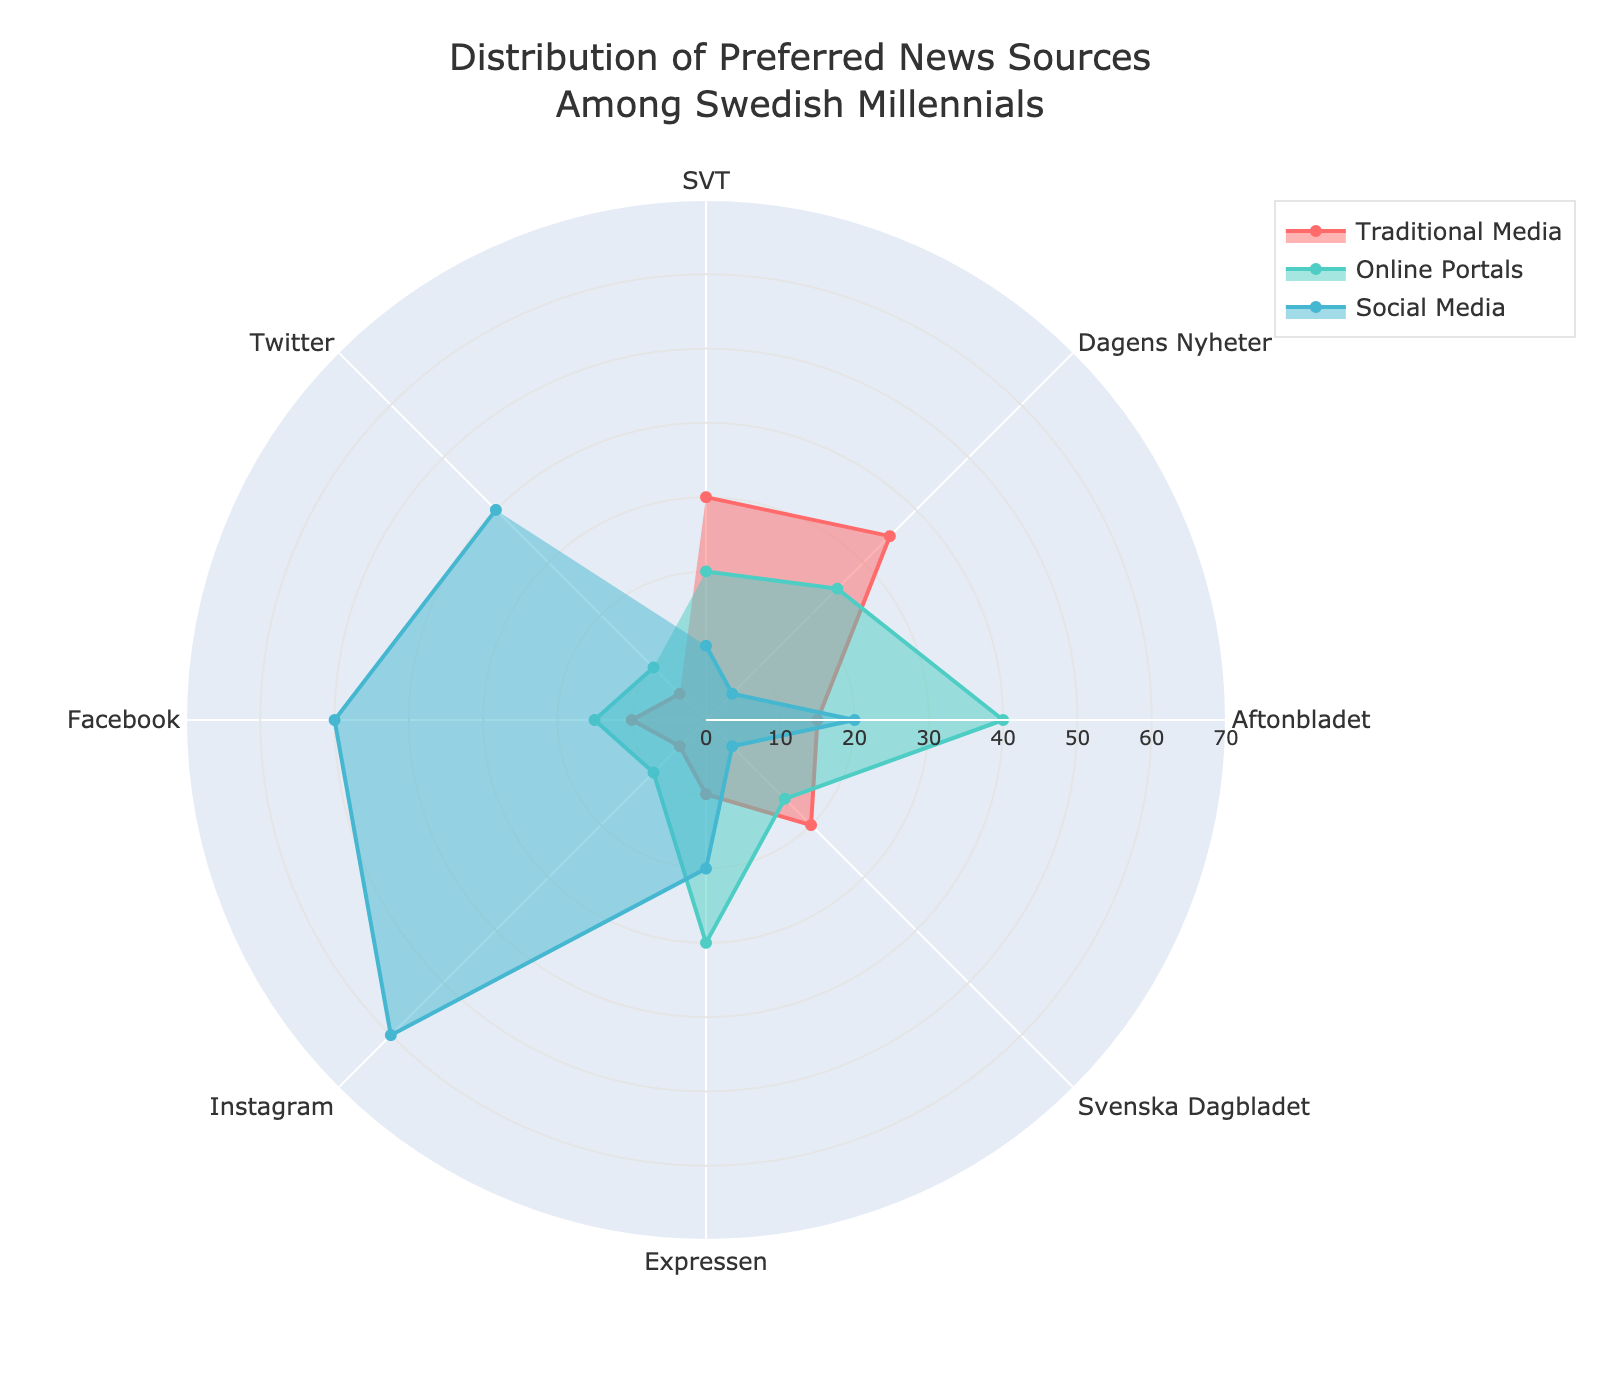What is the highest value for Traditional Media in the chart? The highest value is plotted by looking at where the red-colored area representing Traditional Media peaks. The peak is at Dagens Nyheter with a value of 35.
Answer: 35 Which news source is most preferred on Social Media? The news source with the highest value for Social Media can be found by observing where the blue-colored area peaks. The highest value is Instagram with 60.
Answer: Instagram What is the combined preference for Online Portals for Aftonbladet and Expressen? Add the values for Online Portals of Aftonbladet and Expressen: 40 + 30 = 70
Answer: 70 Which category has the least preference in Traditional Media? The least value for Traditional Media can be identified by looking at the smallest red-colored area. Twitter and Instagram both have the smallest value of 5.
Answer: Twitter or Instagram How does the preference for Traditional Media compare between SVT and Expressen? Compare the values for Traditional Media of SVT and Expressen. SVT has 30, while Expressen has 10, so SVT's preference is higher.
Answer: SVT's preference is higher Which category has a balanced preference among all three types of media? Look for the news source where the three colored areas have similar values. None of the categories show perfectly balanced values, but Svenska Dagbladet comes close with values around the 15-20 range.
Answer: Svenska Dagbladet What's the difference in Social Media preference between Facebook and Aftonbladet? Subtract the Social Media value of Aftonbladet from that of Facebook: 50 - 20 = 30
Answer: 30 What's the most common range for Online Portal preferences based on the categories? Observe the blue-colored areas for Online Portals across all categories. Most values fall within the range of 10 to 30.
Answer: 10 to 30 What is the average preference value for Social Media across all categories? Sum the Social Media values of all categories and divide by the number of categories: (10 + 5 + 20 + 5 + 20 + 60 + 50 + 40) / 8 = 210 / 8 = 26.25
Answer: 26.25 What is the overall distribution for Traditional Media in terms of spread across categories? The Traditional Media values are more varied, ranging from 5 to 35, indicating a wide spread in preferences.
Answer: Wide spread 